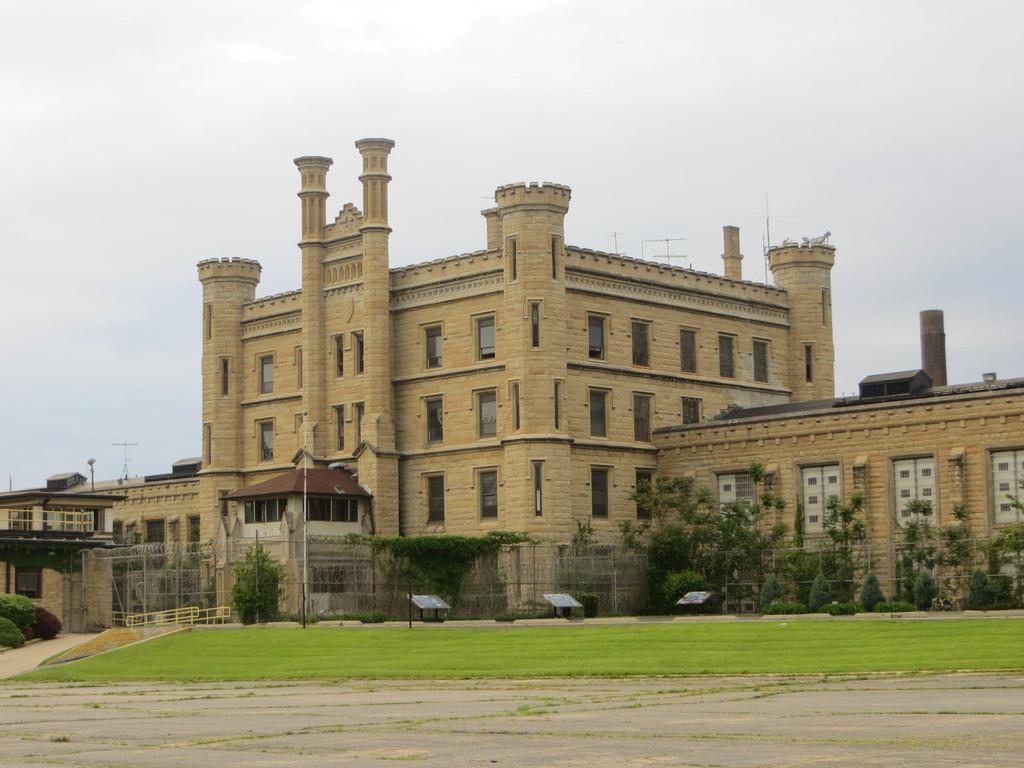How would you summarize this image in a sentence or two? In this image we can see buildings with windows, poles, plants, grass and in the background we can see the sky. 